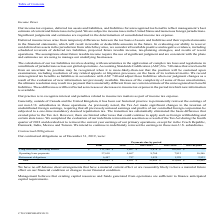According to Cts Corporation's financial document, What does the table show? contractual obligations as of December 31, 2019. The document states: "Our contractual obligations as of December 31, 2019, were:..." Also, What were the Operating lease payments for payments due in 2020? According to the financial document, 4,467. The relevant text states: "Operating lease payments 37,610 4,467 8,764 7,813 16,566..." Also, What were the total contractual obligations? According to the financial document, 155,643. The relevant text states: "Total $ 155,643 $ 8,031 $ 16,069 $ 112,044 $ 19,499..." Also, can you calculate: What was the difference between total Operating lease payments and   Retirement obligations  payments ? Based on the calculation: 37,610-6,447, the result is 31163. This is based on the information: "Retirement obligations 6,447 757 1,429 1,328 2,933 Operating lease payments 37,610 4,467 8,764 7,813 16,566..." The key data points involved are: 37,610, 6,447. Also, can you calculate: What was the difference between payments due in 2023-2024 between Long-term debt, including interest and  Operating lease payments ? Based on the calculation: 102,903-7,813, the result is 95090. This is based on the information: "t, including interest $ 111,586 $ 2,807 $ 5,876 $ 102,903 $ — Operating lease payments 37,610 4,467 8,764 7,813 16,566..." The key data points involved are: 102,903, 7,813. Also, can you calculate: What was the percentage change in the total contractual obligations due between 2020 and 2021-2022? To answer this question, I need to perform calculations using the financial data. The calculation is: (16,069-8,031)/8,031, which equals 100.09 (percentage). This is based on the information: "Total $ 155,643 $ 8,031 $ 16,069 $ 112,044 $ 19,499 Total $ 155,643 $ 8,031 $ 16,069 $ 112,044 $ 19,499..." The key data points involved are: 16,069, 8,031. 